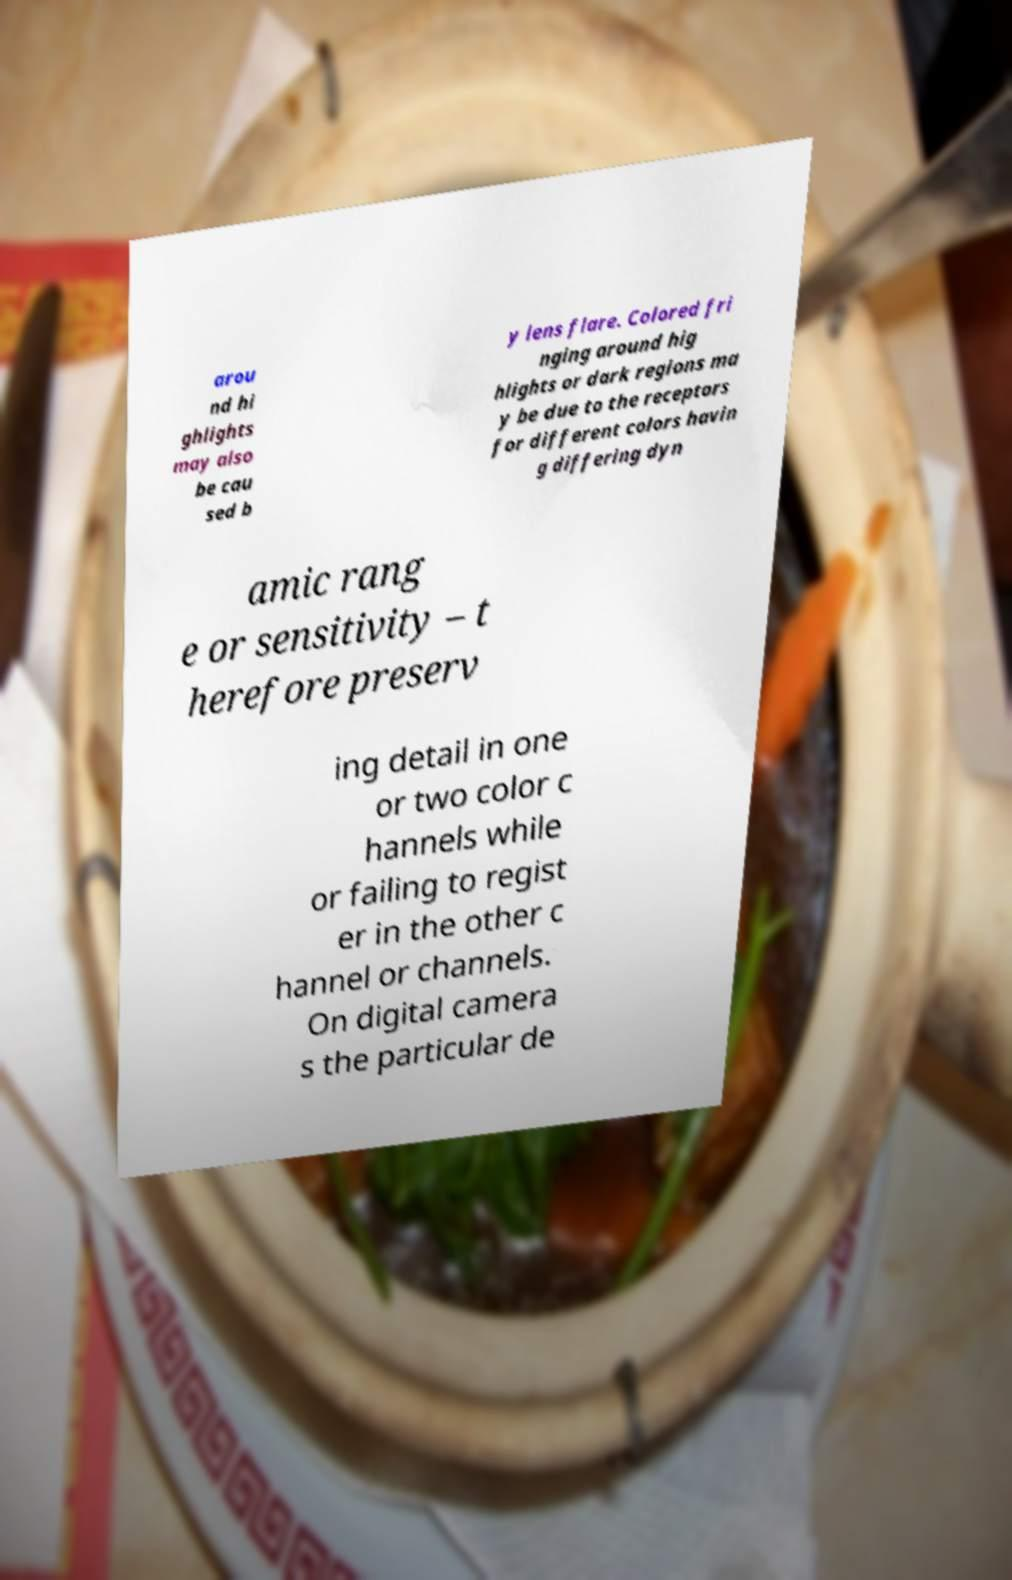Please identify and transcribe the text found in this image. arou nd hi ghlights may also be cau sed b y lens flare. Colored fri nging around hig hlights or dark regions ma y be due to the receptors for different colors havin g differing dyn amic rang e or sensitivity – t herefore preserv ing detail in one or two color c hannels while or failing to regist er in the other c hannel or channels. On digital camera s the particular de 